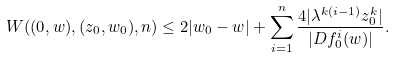<formula> <loc_0><loc_0><loc_500><loc_500>W ( ( 0 , w ) , ( z _ { 0 } , w _ { 0 } ) , n ) \leq 2 | w _ { 0 } - w | + \sum _ { i = 1 } ^ { n } \frac { 4 | \lambda ^ { k ( i - 1 ) } z _ { 0 } ^ { k } | } { | D f _ { 0 } ^ { i } ( w ) | } .</formula> 